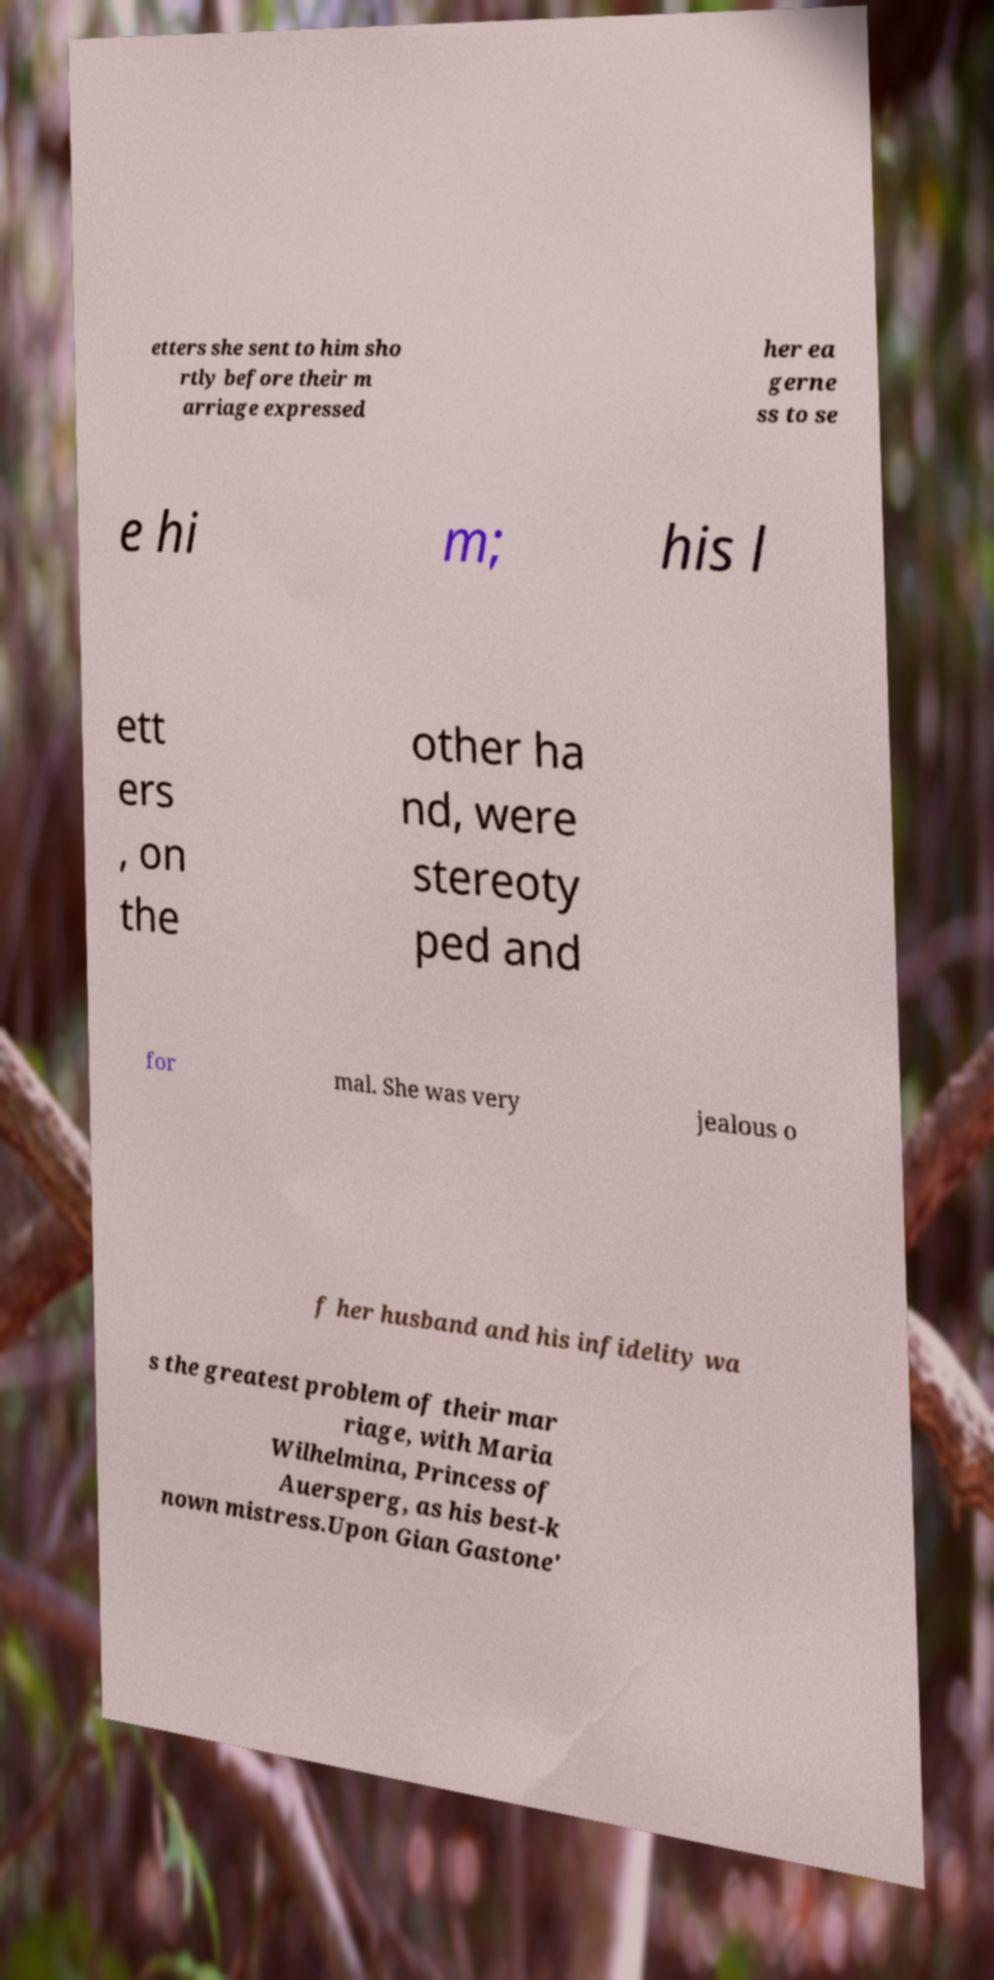Could you assist in decoding the text presented in this image and type it out clearly? etters she sent to him sho rtly before their m arriage expressed her ea gerne ss to se e hi m; his l ett ers , on the other ha nd, were stereoty ped and for mal. She was very jealous o f her husband and his infidelity wa s the greatest problem of their mar riage, with Maria Wilhelmina, Princess of Auersperg, as his best-k nown mistress.Upon Gian Gastone' 